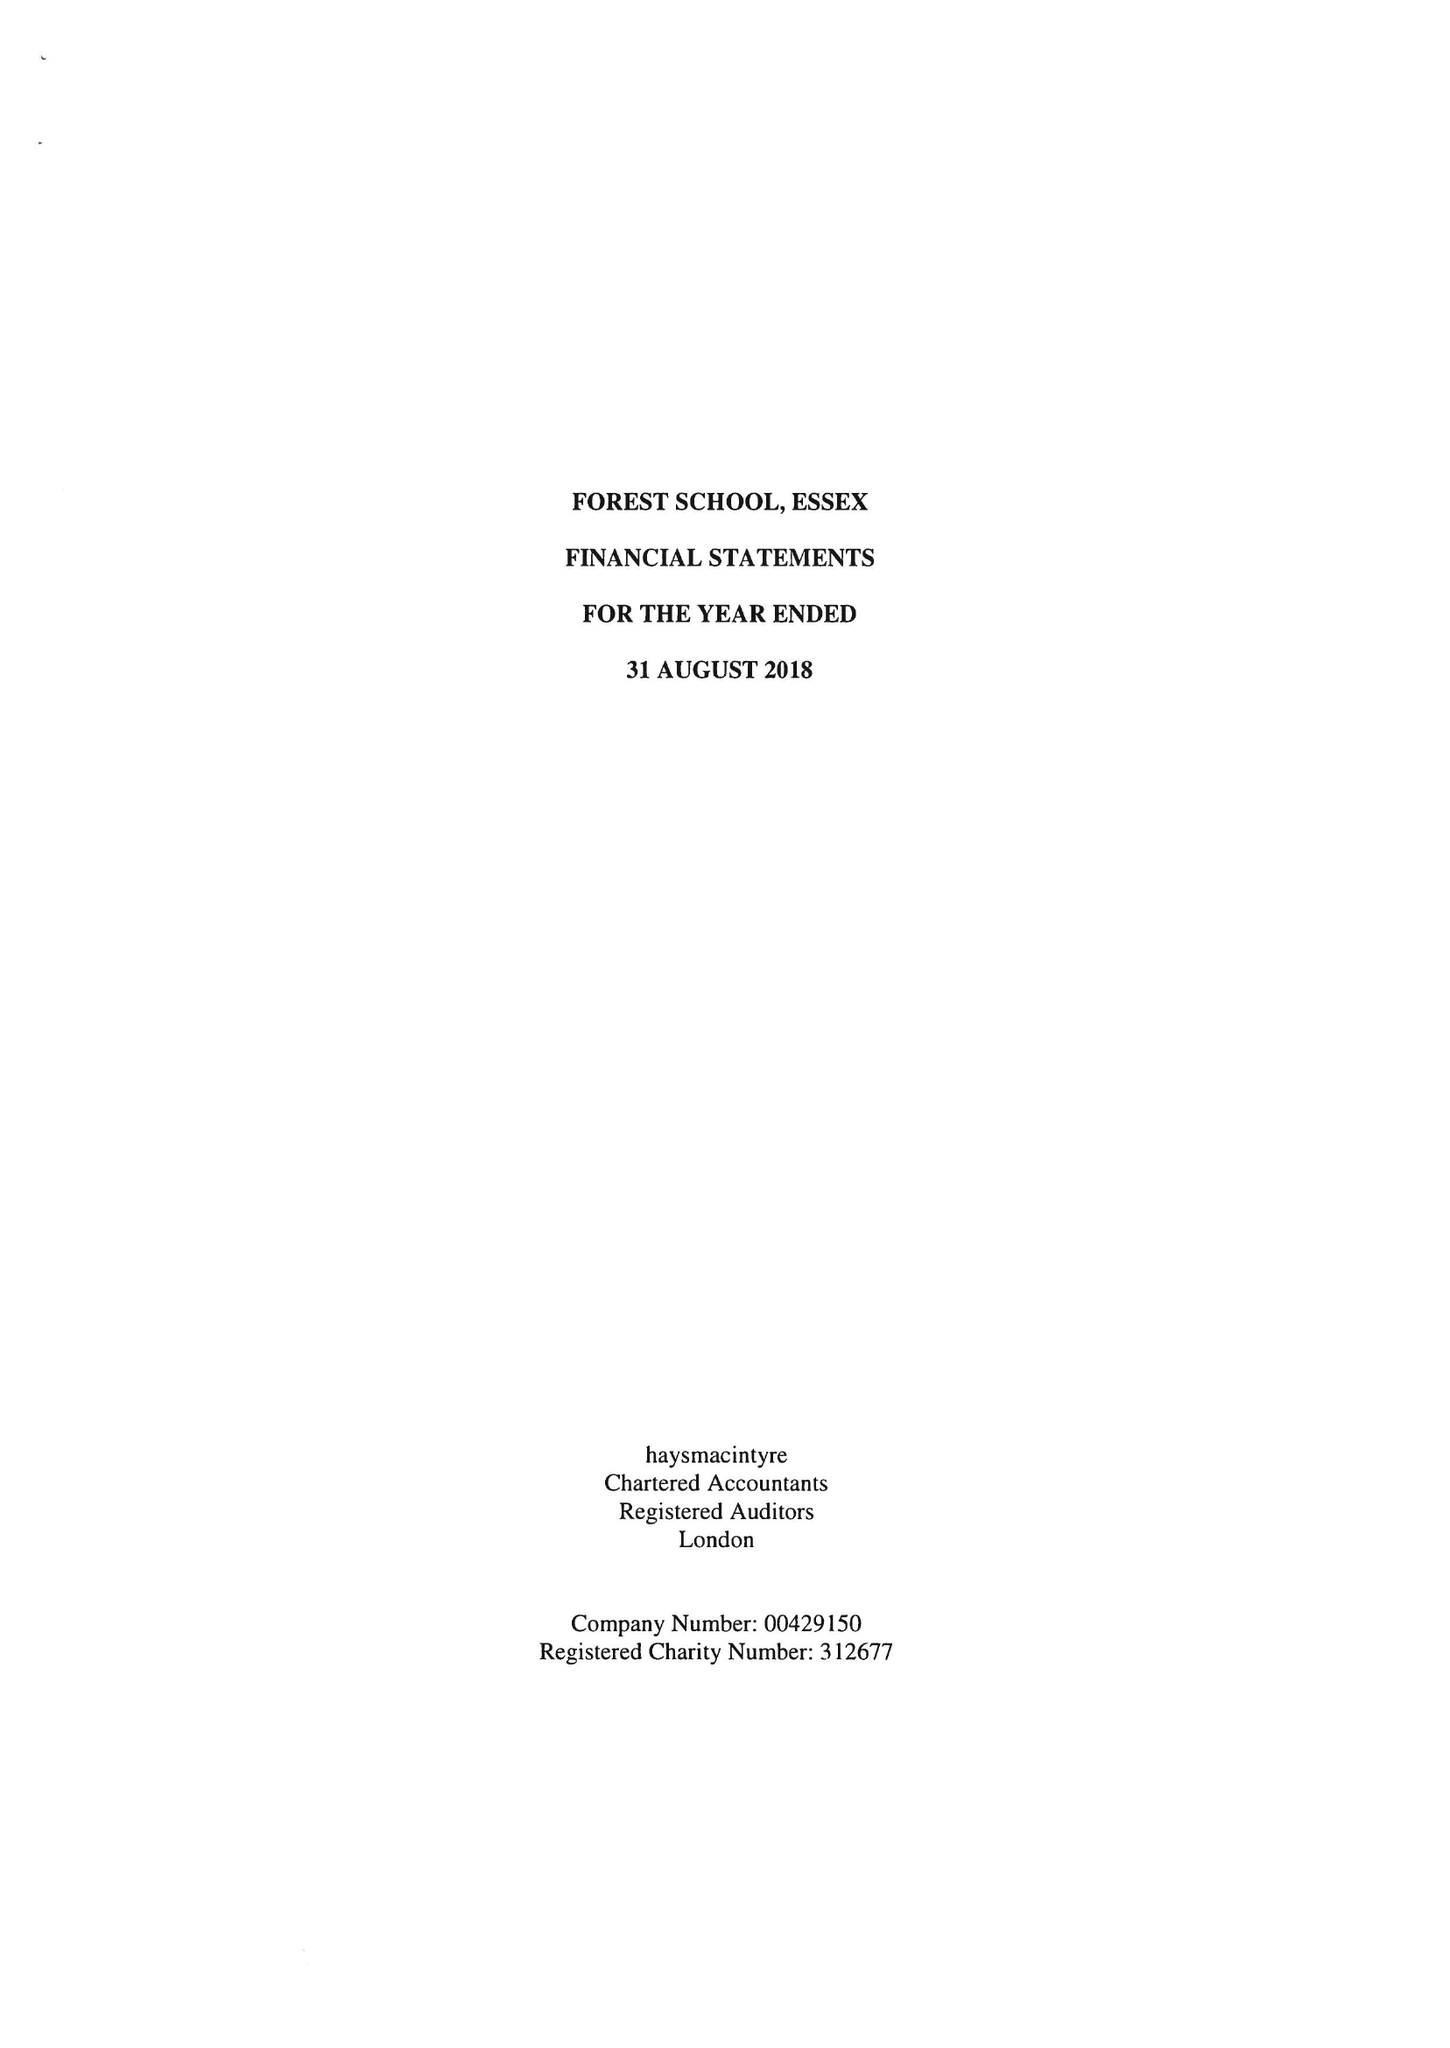What is the value for the spending_annually_in_british_pounds?
Answer the question using a single word or phrase. 22598697.00 